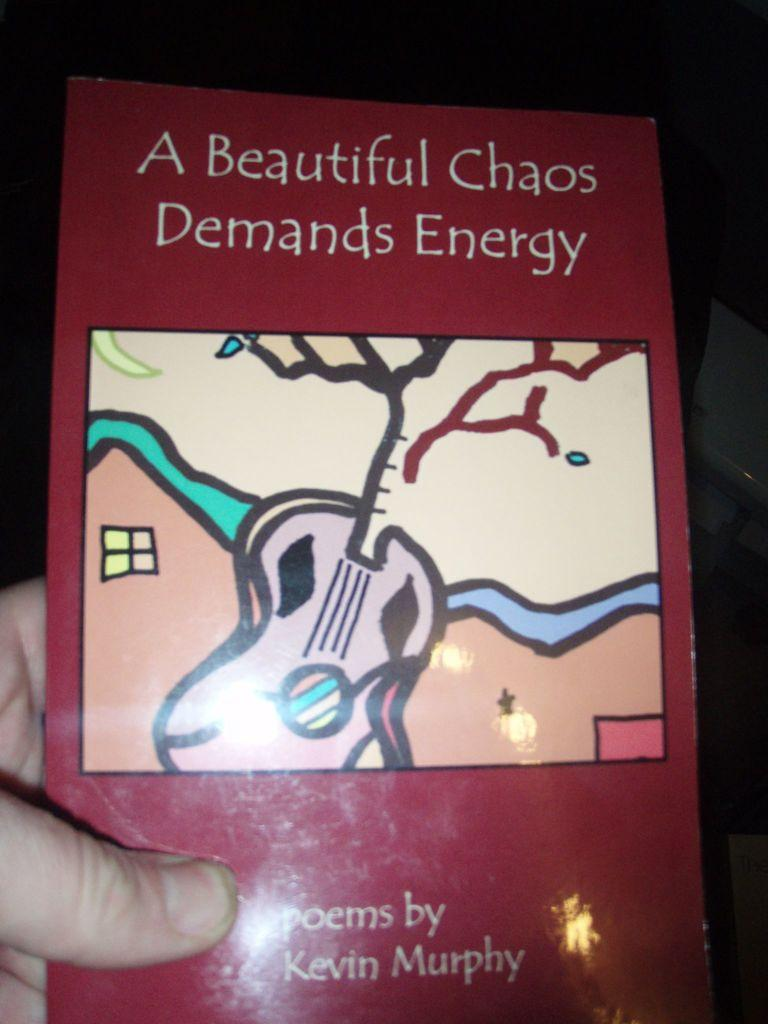<image>
Summarize the visual content of the image. hand holding red book with title a beautiful chaos demands energy 